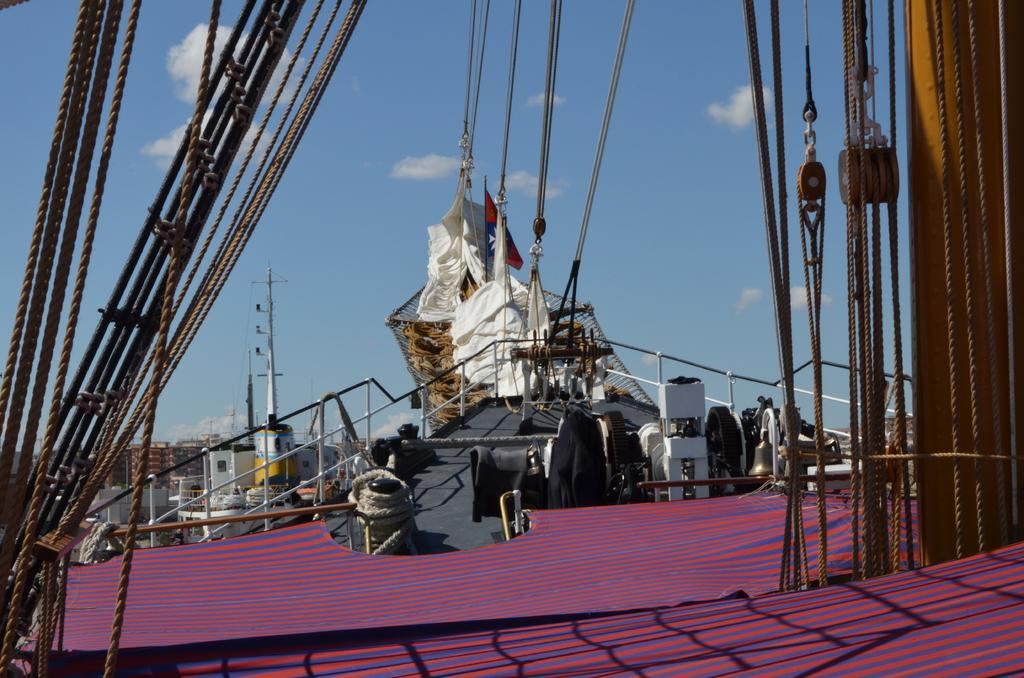What is the main subject of the image? The main subject of the image is a group of ropes. What devices are present in the image that might be used to manipulate the ropes? There are pulleys in the image that might be used to manipulate the ropes. What structures are visible in the image that might be used to support the ropes? There are poles in the image that might be used to support the ropes. What is visible in the background of the image? The sky is visible in the background of the image. What type of battle is taking place in the image? There is no battle present in the image; it features a group of ropes, pulleys, and poles. What color is the scarf that is being worn by one of the ropes in the image? There is no scarf present in the image; it features a group of ropes, pulleys, and poles. 